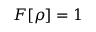<formula> <loc_0><loc_0><loc_500><loc_500>F [ \rho ] = 1</formula> 